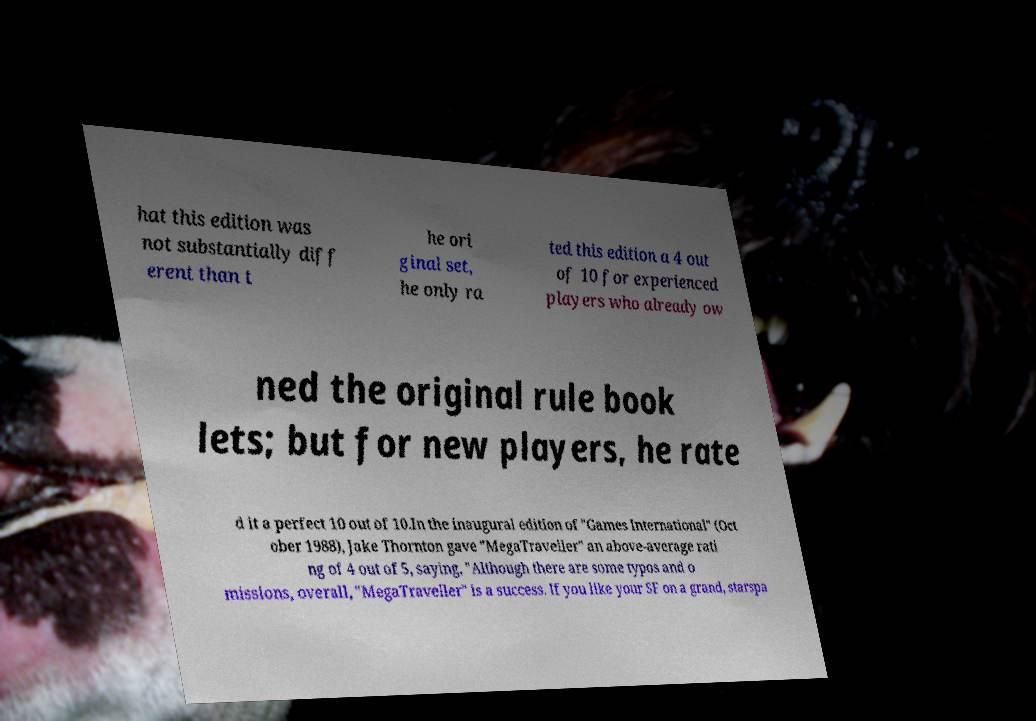For documentation purposes, I need the text within this image transcribed. Could you provide that? hat this edition was not substantially diff erent than t he ori ginal set, he only ra ted this edition a 4 out of 10 for experienced players who already ow ned the original rule book lets; but for new players, he rate d it a perfect 10 out of 10.In the inaugural edition of "Games International" (Oct ober 1988), Jake Thornton gave "MegaTraveller" an above-average rati ng of 4 out of 5, saying, "Although there are some typos and o missions, overall, "MegaTraveller" is a success. If you like your SF on a grand, starspa 